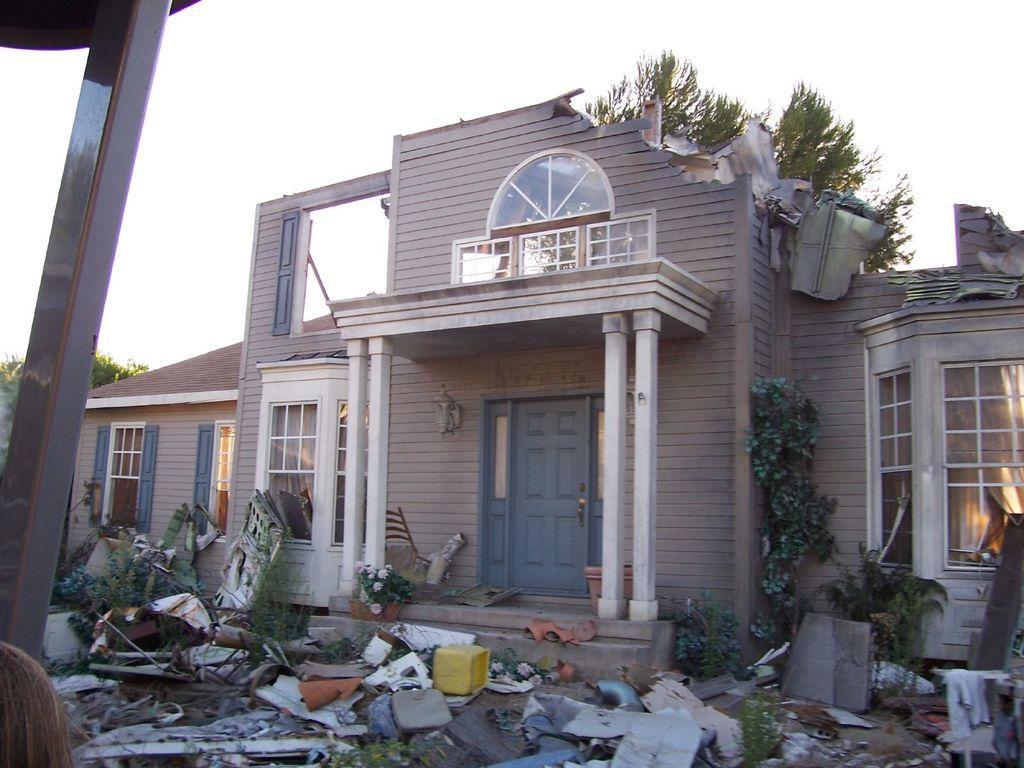Can you describe this image briefly? In this image there is a collapsed building, in front of that there is a garbage, behind that there are some trees. 